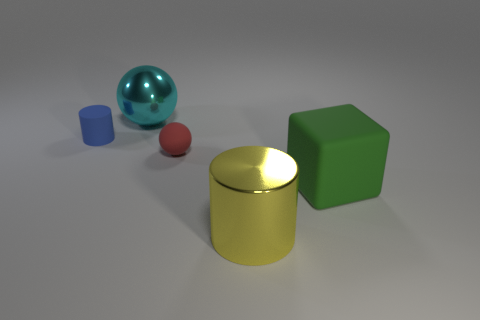What is the color of the other object that is the same shape as the yellow thing?
Your answer should be compact. Blue. Is there a tiny blue matte object of the same shape as the big green matte object?
Make the answer very short. No. There is a blue rubber object that is the same size as the rubber ball; what shape is it?
Provide a succinct answer. Cylinder. What is the material of the tiny ball that is to the right of the shiny object on the left side of the big metallic object in front of the blue rubber cylinder?
Ensure brevity in your answer.  Rubber. Does the green rubber block have the same size as the red thing?
Your answer should be compact. No. What material is the large green thing?
Your answer should be very brief. Rubber. There is a large metal object on the right side of the big cyan ball; is it the same shape as the small blue thing?
Ensure brevity in your answer.  Yes. How many objects are small blue objects or small matte spheres?
Keep it short and to the point. 2. Are the object that is behind the tiny rubber cylinder and the blue cylinder made of the same material?
Keep it short and to the point. No. How big is the blue rubber thing?
Provide a succinct answer. Small. 